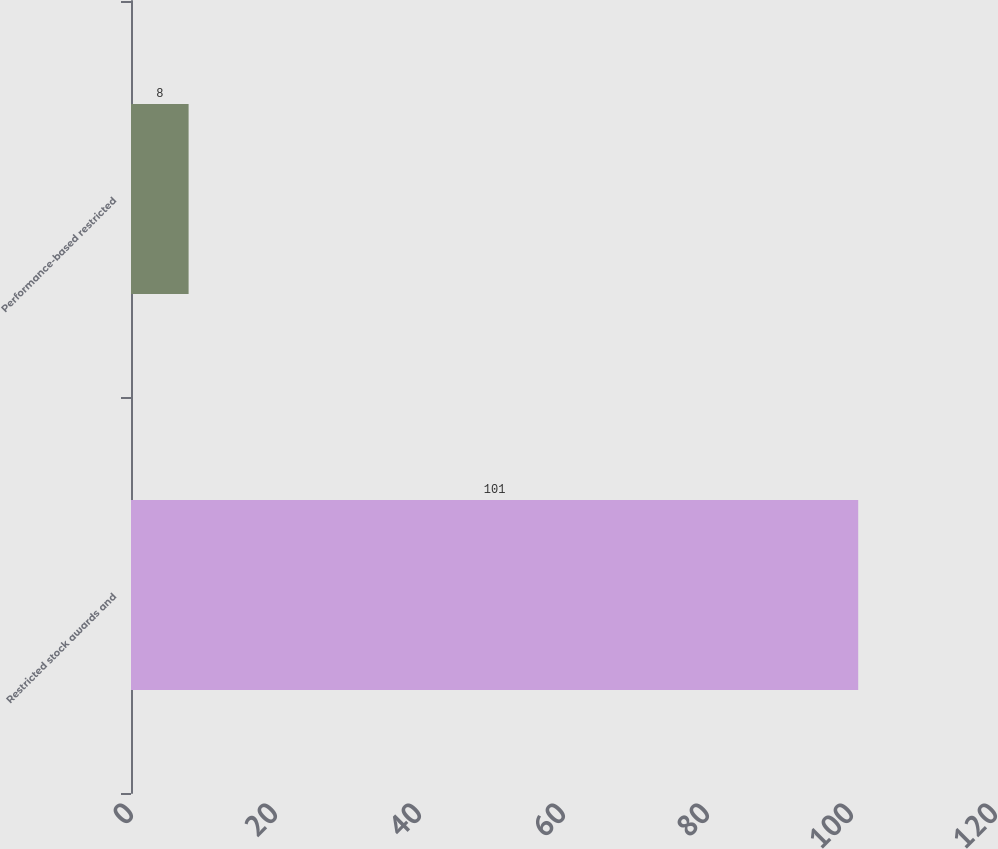<chart> <loc_0><loc_0><loc_500><loc_500><bar_chart><fcel>Restricted stock awards and<fcel>Performance-based restricted<nl><fcel>101<fcel>8<nl></chart> 